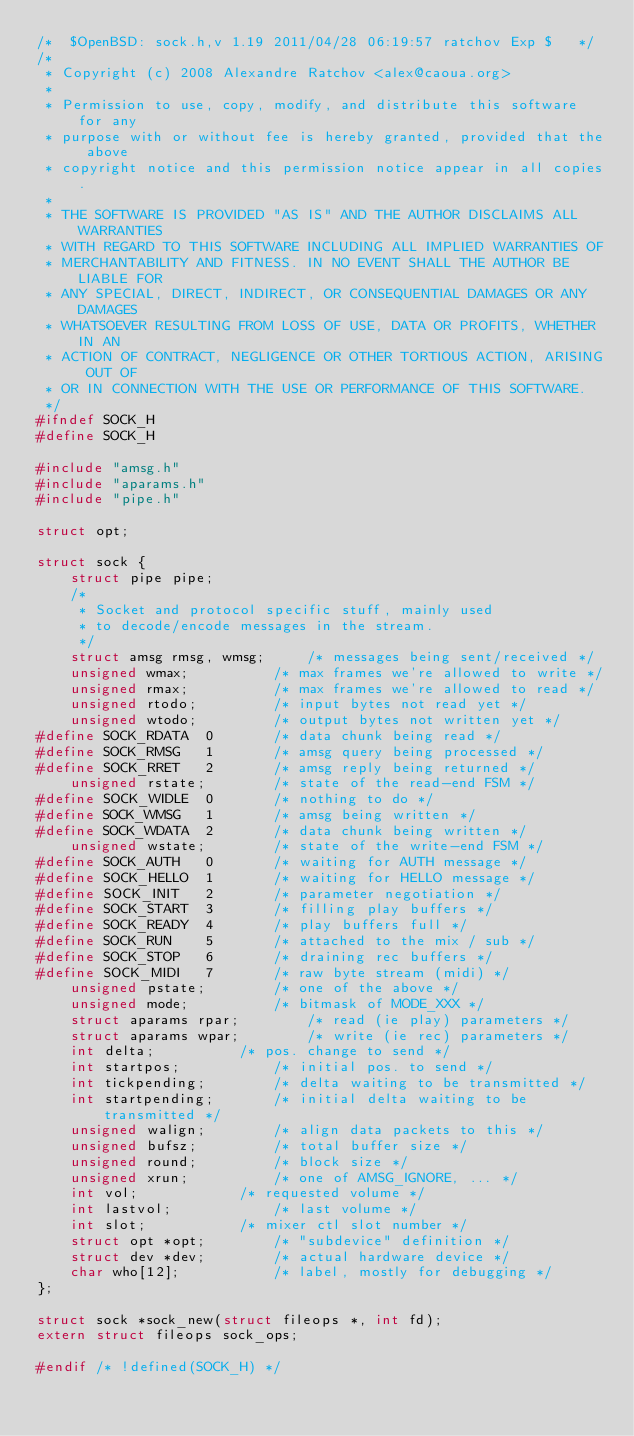<code> <loc_0><loc_0><loc_500><loc_500><_C_>/*	$OpenBSD: sock.h,v 1.19 2011/04/28 06:19:57 ratchov Exp $	*/
/*
 * Copyright (c) 2008 Alexandre Ratchov <alex@caoua.org>
 *
 * Permission to use, copy, modify, and distribute this software for any
 * purpose with or without fee is hereby granted, provided that the above
 * copyright notice and this permission notice appear in all copies.
 *
 * THE SOFTWARE IS PROVIDED "AS IS" AND THE AUTHOR DISCLAIMS ALL WARRANTIES
 * WITH REGARD TO THIS SOFTWARE INCLUDING ALL IMPLIED WARRANTIES OF
 * MERCHANTABILITY AND FITNESS. IN NO EVENT SHALL THE AUTHOR BE LIABLE FOR
 * ANY SPECIAL, DIRECT, INDIRECT, OR CONSEQUENTIAL DAMAGES OR ANY DAMAGES
 * WHATSOEVER RESULTING FROM LOSS OF USE, DATA OR PROFITS, WHETHER IN AN
 * ACTION OF CONTRACT, NEGLIGENCE OR OTHER TORTIOUS ACTION, ARISING OUT OF
 * OR IN CONNECTION WITH THE USE OR PERFORMANCE OF THIS SOFTWARE.
 */
#ifndef SOCK_H
#define SOCK_H

#include "amsg.h"
#include "aparams.h"
#include "pipe.h"

struct opt;

struct sock {
	struct pipe pipe;
	/*
	 * Socket and protocol specific stuff, mainly used
	 * to decode/encode messages in the stream.
	 */
	struct amsg rmsg, wmsg;		/* messages being sent/received */
	unsigned wmax;			/* max frames we're allowed to write */
	unsigned rmax;			/* max frames we're allowed to read */
	unsigned rtodo;			/* input bytes not read yet */
	unsigned wtodo;			/* output bytes not written yet */
#define SOCK_RDATA	0		/* data chunk being read */
#define SOCK_RMSG	1		/* amsg query being processed */
#define SOCK_RRET	2		/* amsg reply being returned */
	unsigned rstate;		/* state of the read-end FSM */
#define SOCK_WIDLE	0		/* nothing to do */
#define SOCK_WMSG	1		/* amsg being written */
#define SOCK_WDATA	2		/* data chunk being written */
	unsigned wstate;		/* state of the write-end FSM */
#define SOCK_AUTH	0		/* waiting for AUTH message */
#define SOCK_HELLO	1		/* waiting for HELLO message */
#define SOCK_INIT	2		/* parameter negotiation */
#define SOCK_START	3		/* filling play buffers */
#define SOCK_READY	4		/* play buffers full */
#define SOCK_RUN	5		/* attached to the mix / sub */
#define SOCK_STOP	6		/* draining rec buffers */
#define SOCK_MIDI	7		/* raw byte stream (midi) */
	unsigned pstate;		/* one of the above */
	unsigned mode;			/* bitmask of MODE_XXX */
	struct aparams rpar;		/* read (ie play) parameters */
	struct aparams wpar;		/* write (ie rec) parameters */
	int delta;			/* pos. change to send */
	int startpos;			/* initial pos. to send */
	int tickpending;		/* delta waiting to be transmitted */
	int startpending;		/* initial delta waiting to be transmitted */
	unsigned walign;		/* align data packets to this */
	unsigned bufsz;			/* total buffer size */
	unsigned round;			/* block size */
	unsigned xrun;			/* one of AMSG_IGNORE, ... */
	int vol;			/* requested volume */
	int lastvol;			/* last volume */
	int slot;			/* mixer ctl slot number */
	struct opt *opt;		/* "subdevice" definition */
	struct dev *dev;		/* actual hardware device */
	char who[12];			/* label, mostly for debugging */
};

struct sock *sock_new(struct fileops *, int fd);
extern struct fileops sock_ops;

#endif /* !defined(SOCK_H) */
</code> 